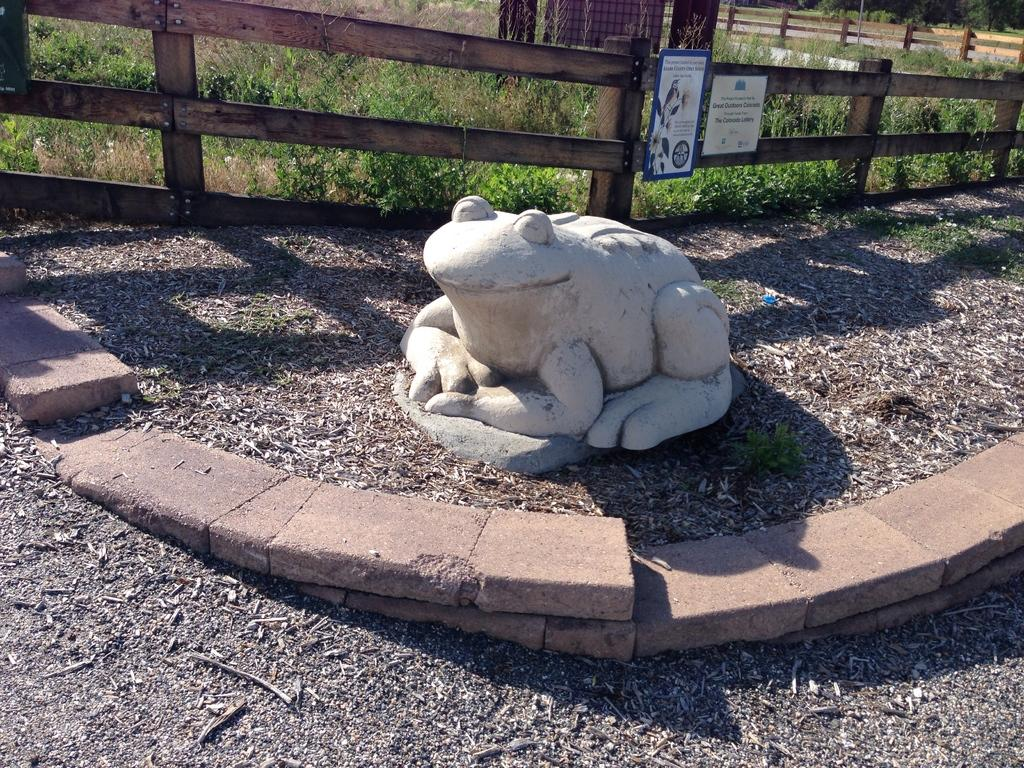What type of statue is present in the image? There is a frog statue in the image. What kind of barrier can be seen in the image? There is a wooden fence in the image. What type of vegetation is present in the image? There are plants and trees in the image. What type of signage is present in the image? There are advertisement boards in the image. What type of rings can be seen on the frog statue in the image? There are no rings present on the frog statue in the image. The image does not show any rings on the frog statue, so we cannot determine if there are any rings present. 